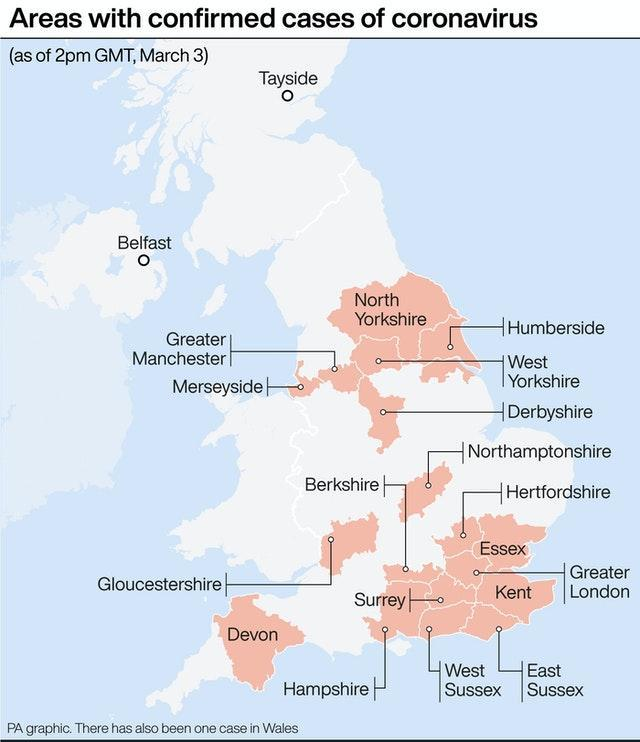How many places are shown in pink colour?
Answer the question with a short phrase. 19 